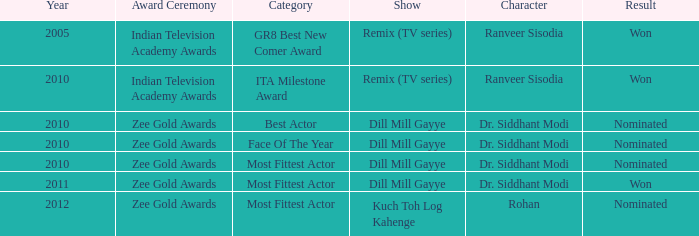At the indian television academy awards, which series was up for the ita milestone award? Remix (TV series). 